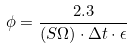<formula> <loc_0><loc_0><loc_500><loc_500>\phi = \frac { 2 . 3 } { ( S \Omega ) \cdot \Delta t \cdot \epsilon }</formula> 